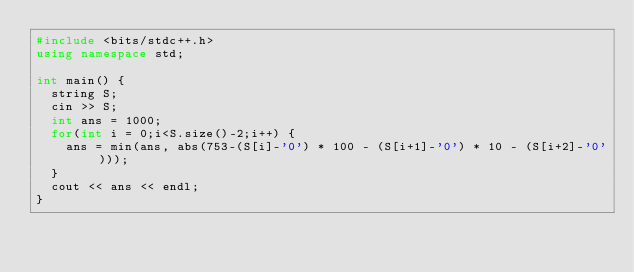Convert code to text. <code><loc_0><loc_0><loc_500><loc_500><_C++_>#include <bits/stdc++.h>
using namespace std;

int main() {
  string S;
  cin >> S;
  int ans = 1000;
  for(int i = 0;i<S.size()-2;i++) {
    ans = min(ans, abs(753-(S[i]-'0') * 100 - (S[i+1]-'0') * 10 - (S[i+2]-'0')));
  }
  cout << ans << endl;
}</code> 